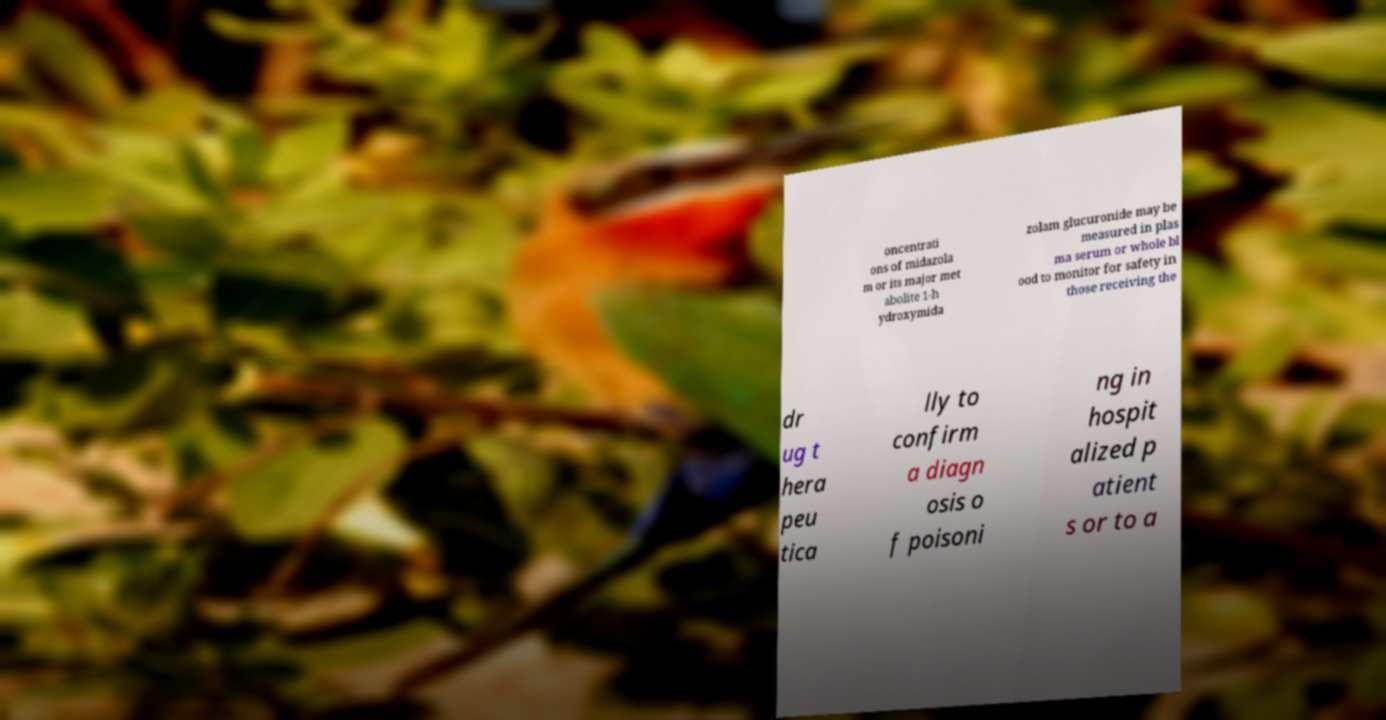There's text embedded in this image that I need extracted. Can you transcribe it verbatim? oncentrati ons of midazola m or its major met abolite 1-h ydroxymida zolam glucuronide may be measured in plas ma serum or whole bl ood to monitor for safety in those receiving the dr ug t hera peu tica lly to confirm a diagn osis o f poisoni ng in hospit alized p atient s or to a 